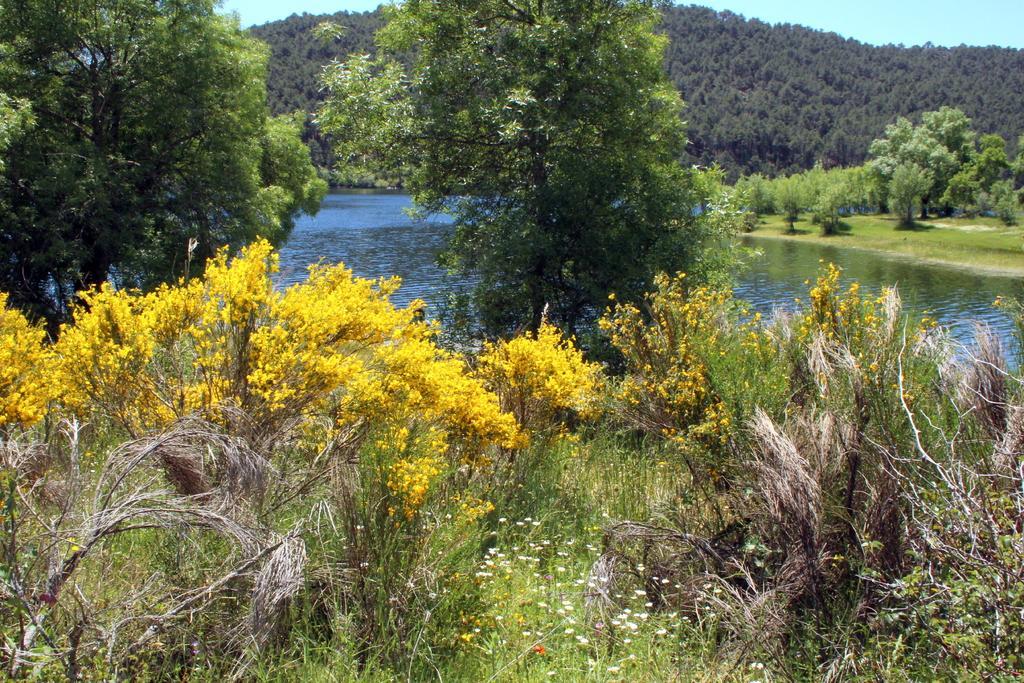Describe this image in one or two sentences. In this image, we can see trees, plants and flowers. Background we can see water, grass, trees, hill and sky. 